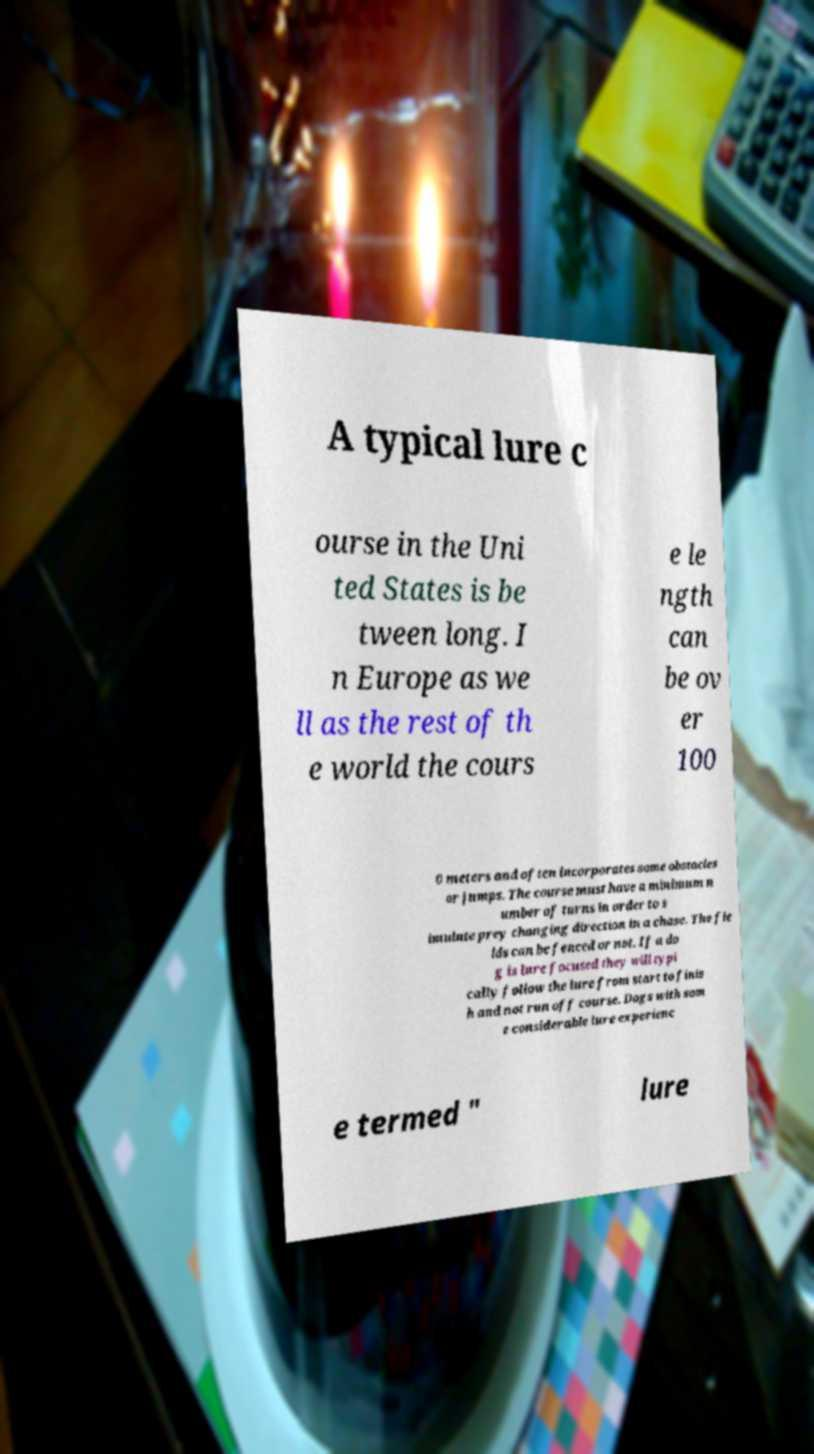Please identify and transcribe the text found in this image. A typical lure c ourse in the Uni ted States is be tween long. I n Europe as we ll as the rest of th e world the cours e le ngth can be ov er 100 0 meters and often incorporates some obstacles or jumps. The course must have a minimum n umber of turns in order to s imulate prey changing direction in a chase. The fie lds can be fenced or not. If a do g is lure focused they will typi cally follow the lure from start to finis h and not run off course. Dogs with som e considerable lure experienc e termed " lure 